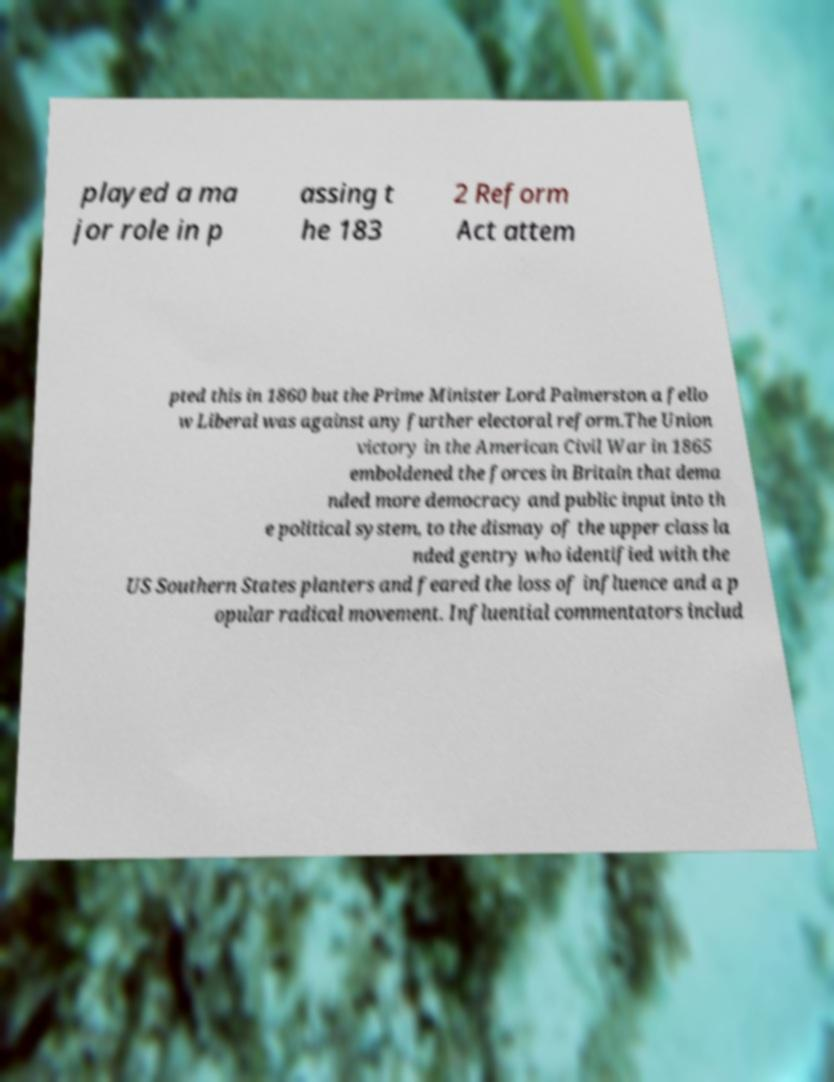Please identify and transcribe the text found in this image. played a ma jor role in p assing t he 183 2 Reform Act attem pted this in 1860 but the Prime Minister Lord Palmerston a fello w Liberal was against any further electoral reform.The Union victory in the American Civil War in 1865 emboldened the forces in Britain that dema nded more democracy and public input into th e political system, to the dismay of the upper class la nded gentry who identified with the US Southern States planters and feared the loss of influence and a p opular radical movement. Influential commentators includ 